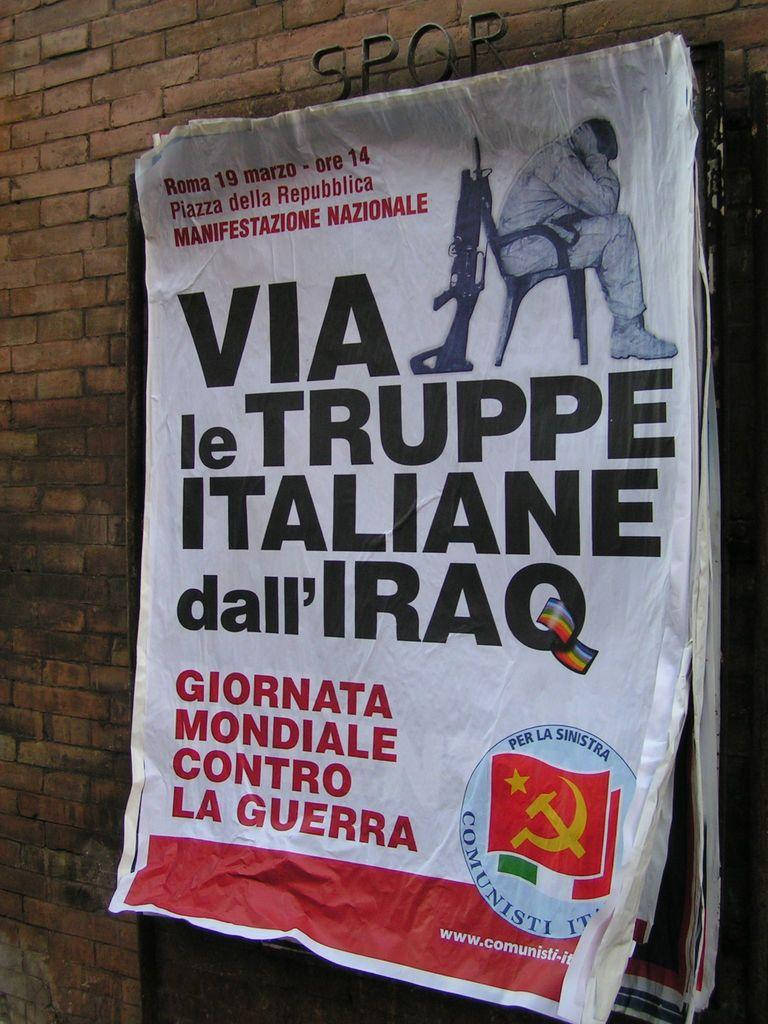Provide a one-sentence caption for the provided image. The poster on the building says "VIA le TRUPPE ITALIANE dall'IRAQ. 